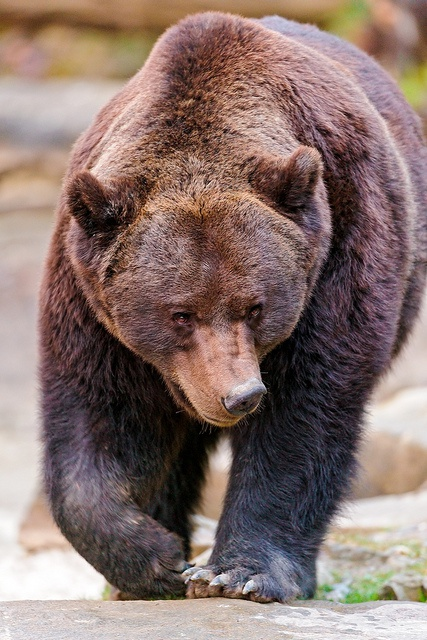Describe the objects in this image and their specific colors. I can see a bear in tan, black, gray, and maroon tones in this image. 